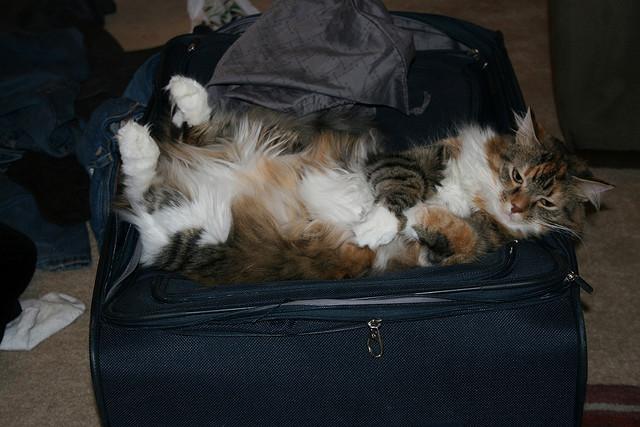Are the clothes in the picture clean or dirty?
Keep it brief. Dirty. What color is the cat?
Short answer required. Brown and white. Is this a young kitten?
Answer briefly. No. What is the cat doing in the suitcase?
Write a very short answer. Laying. Where is the cat?
Short answer required. Suitcase. 